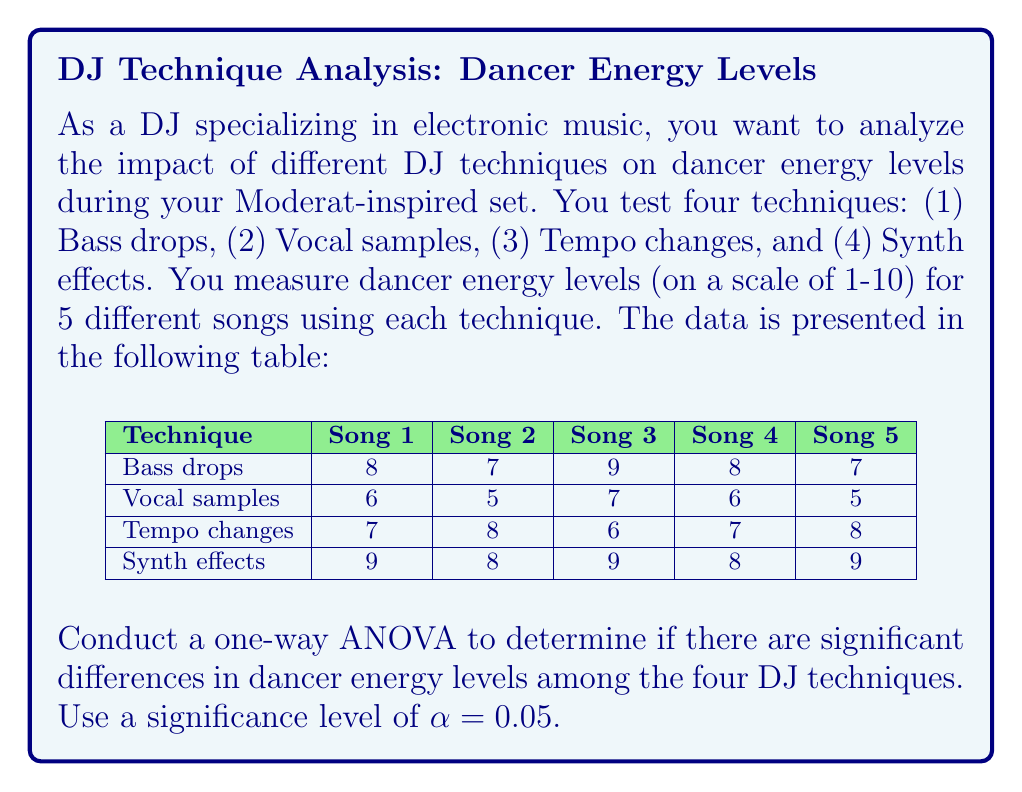Teach me how to tackle this problem. Let's perform the one-way ANOVA step by step:

1. State the hypotheses:
   $H_0$: All group means are equal (μ₁ = μ₂ = μ₃ = μ₄)
   $H_a$: At least one group mean is different

2. Calculate the total sum of squares (SST):
   $$SST = \sum_{i=1}^{n} (x_i - \bar{x})^2$$
   where $x_i$ are all individual observations and $\bar{x}$ is the grand mean.

3. Calculate the between-group sum of squares (SSB):
   $$SSB = \sum_{j=1}^{k} n_j(\bar{x}_j - \bar{x})^2$$
   where $k$ is the number of groups, $n_j$ is the size of each group, and $\bar{x}_j$ is the mean of each group.

4. Calculate the within-group sum of squares (SSW):
   $$SSW = SST - SSB$$

5. Calculate degrees of freedom:
   $df_{between} = k - 1 = 4 - 1 = 3$
   $df_{within} = N - k = 20 - 4 = 16$
   $df_{total} = N - 1 = 20 - 1 = 19$

6. Calculate mean squares:
   $$MS_{between} = \frac{SSB}{df_{between}}$$
   $$MS_{within} = \frac{SSW}{df_{within}}$$

7. Calculate the F-statistic:
   $$F = \frac{MS_{between}}{MS_{within}}$$

8. Find the critical F-value:
   $F_{crit} = F_{0.05,3,16}$ (from F-distribution table)

9. Make a decision:
   If $F > F_{crit}$, reject $H_0$. Otherwise, fail to reject $H_0$.

Performing these calculations:

SST = 44.95
SSB = 35.75
SSW = 9.2

$MS_{between} = 35.75 / 3 = 11.92$
$MS_{within} = 9.2 / 16 = 0.575$

$F = 11.92 / 0.575 = 20.73$

$F_{crit} = 3.24$ (from F-distribution table)

Since $20.73 > 3.24$, we reject the null hypothesis.
Answer: Reject $H_0$; significant differences exist among DJ techniques (F = 20.73, p < 0.05). 